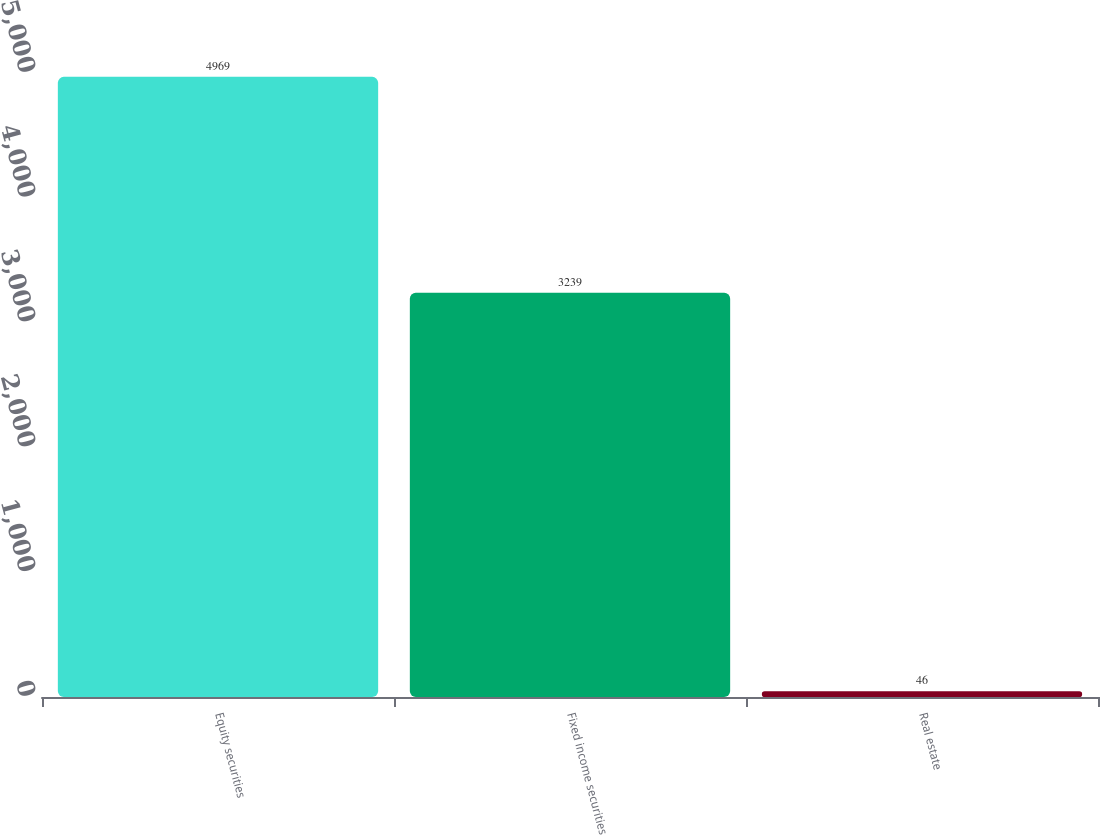Convert chart to OTSL. <chart><loc_0><loc_0><loc_500><loc_500><bar_chart><fcel>Equity securities<fcel>Fixed income securities<fcel>Real estate<nl><fcel>4969<fcel>3239<fcel>46<nl></chart> 